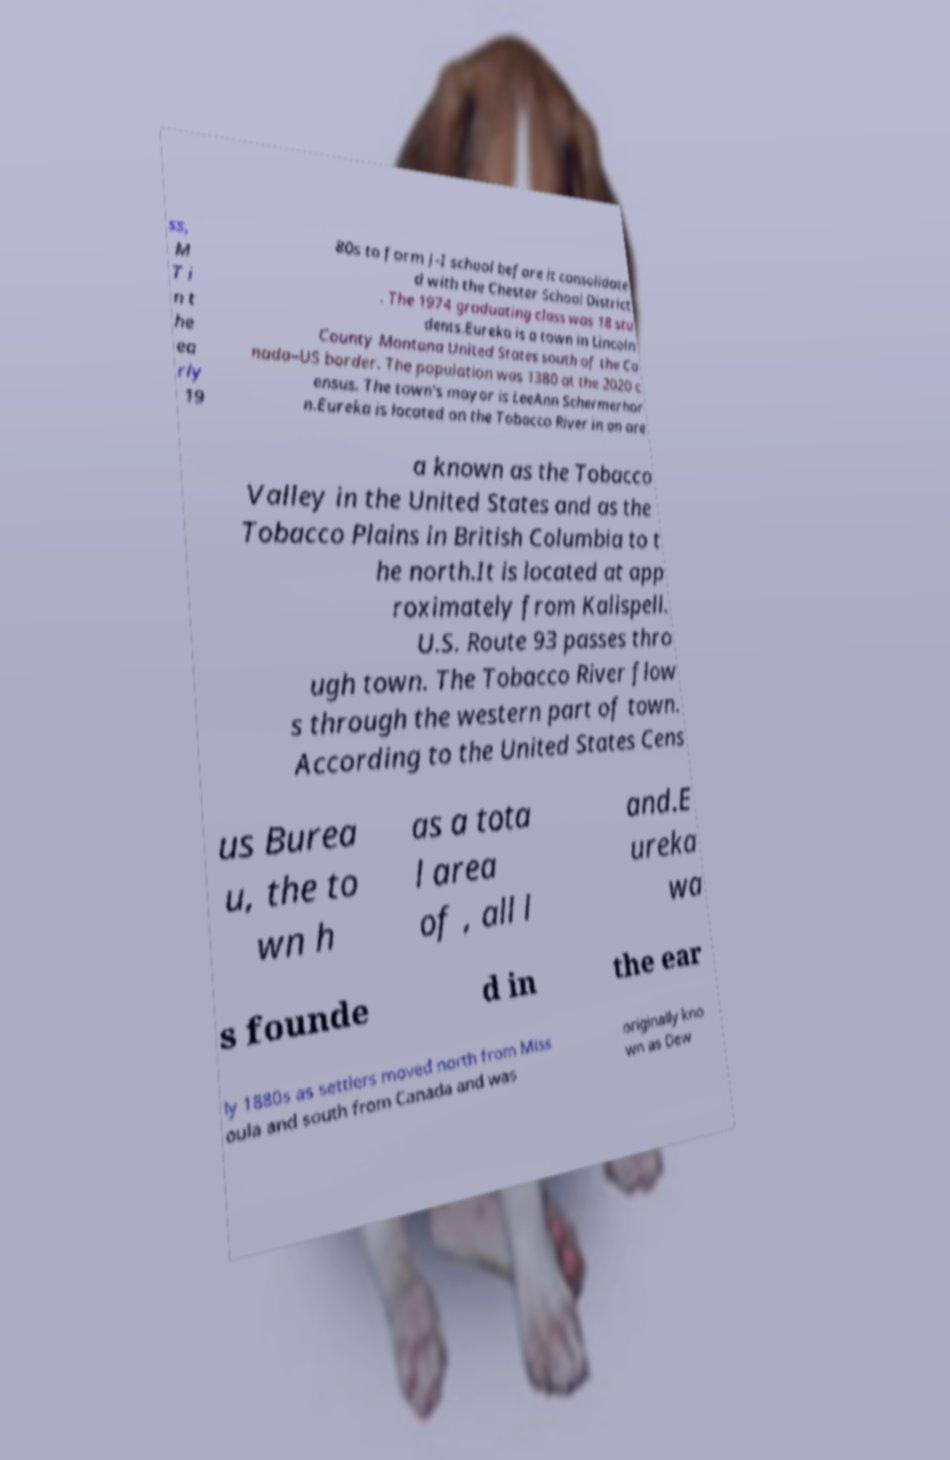I need the written content from this picture converted into text. Can you do that? ss, M T i n t he ea rly 19 80s to form J-I school before it consolidate d with the Chester School District . The 1974 graduating class was 18 stu dents.Eureka is a town in Lincoln County Montana United States south of the Ca nada–US border. The population was 1380 at the 2020 c ensus. The town's mayor is LeeAnn Schermerhor n.Eureka is located on the Tobacco River in an are a known as the Tobacco Valley in the United States and as the Tobacco Plains in British Columbia to t he north.It is located at app roximately from Kalispell. U.S. Route 93 passes thro ugh town. The Tobacco River flow s through the western part of town. According to the United States Cens us Burea u, the to wn h as a tota l area of , all l and.E ureka wa s founde d in the ear ly 1880s as settlers moved north from Miss oula and south from Canada and was originally kno wn as Dew 